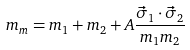<formula> <loc_0><loc_0><loc_500><loc_500>m _ { m } = m _ { 1 } + m _ { 2 } + A \frac { \vec { \sigma } _ { 1 } \cdot \vec { \sigma } _ { 2 } } { m _ { 1 } m _ { 2 } }</formula> 